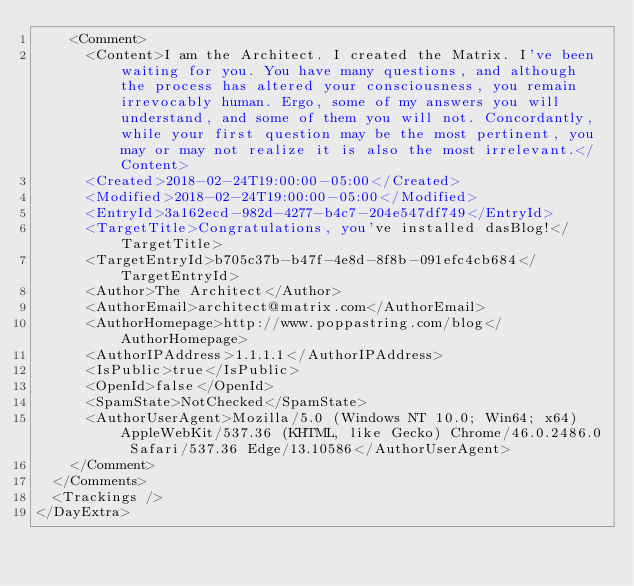Convert code to text. <code><loc_0><loc_0><loc_500><loc_500><_XML_>    <Comment>
      <Content>I am the Architect. I created the Matrix. I've been waiting for you. You have many questions, and although the process has altered your consciousness, you remain irrevocably human. Ergo, some of my answers you will understand, and some of them you will not. Concordantly, while your first question may be the most pertinent, you may or may not realize it is also the most irrelevant.</Content>
      <Created>2018-02-24T19:00:00-05:00</Created>
      <Modified>2018-02-24T19:00:00-05:00</Modified>
      <EntryId>3a162ecd-982d-4277-b4c7-204e547df749</EntryId>
      <TargetTitle>Congratulations, you've installed dasBlog!</TargetTitle>
      <TargetEntryId>b705c37b-b47f-4e8d-8f8b-091efc4cb684</TargetEntryId>
      <Author>The Architect</Author>
      <AuthorEmail>architect@matrix.com</AuthorEmail>
      <AuthorHomepage>http://www.poppastring.com/blog</AuthorHomepage>
      <AuthorIPAddress>1.1.1.1</AuthorIPAddress>
      <IsPublic>true</IsPublic>
      <OpenId>false</OpenId>
      <SpamState>NotChecked</SpamState>
      <AuthorUserAgent>Mozilla/5.0 (Windows NT 10.0; Win64; x64) AppleWebKit/537.36 (KHTML, like Gecko) Chrome/46.0.2486.0 Safari/537.36 Edge/13.10586</AuthorUserAgent>
    </Comment>
  </Comments>
  <Trackings />
</DayExtra></code> 